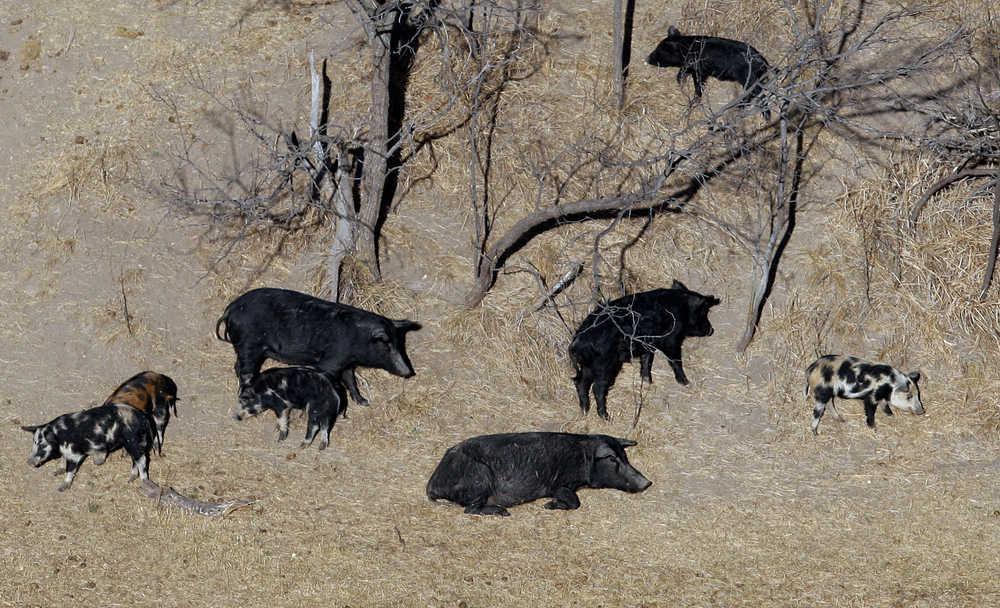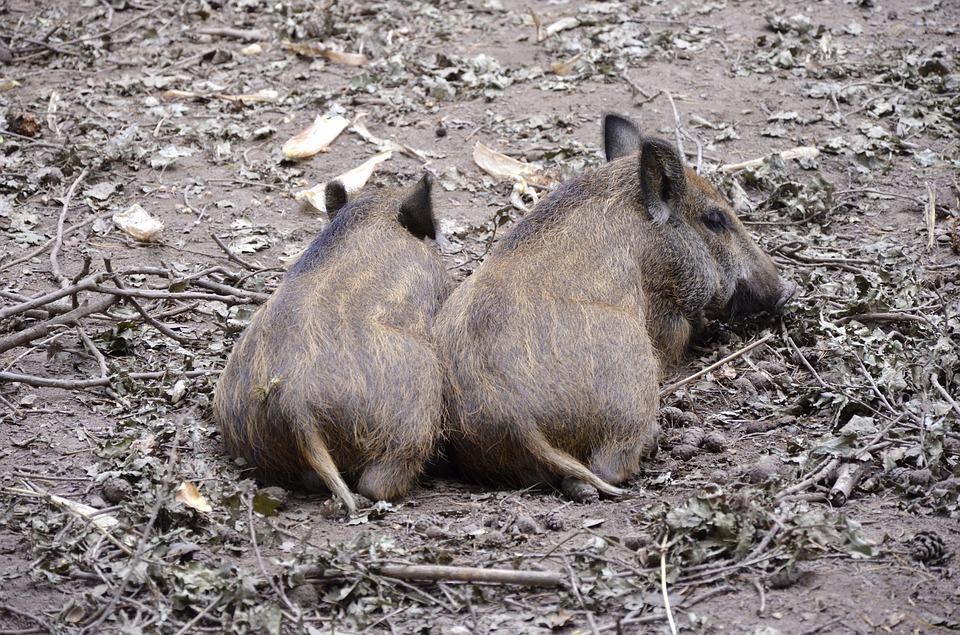The first image is the image on the left, the second image is the image on the right. Evaluate the accuracy of this statement regarding the images: "There are two hogs with at least one baby in the image.". Is it true? Answer yes or no. Yes. The first image is the image on the left, the second image is the image on the right. Examine the images to the left and right. Is the description "The left image contains no more than three wild boars." accurate? Answer yes or no. No. 